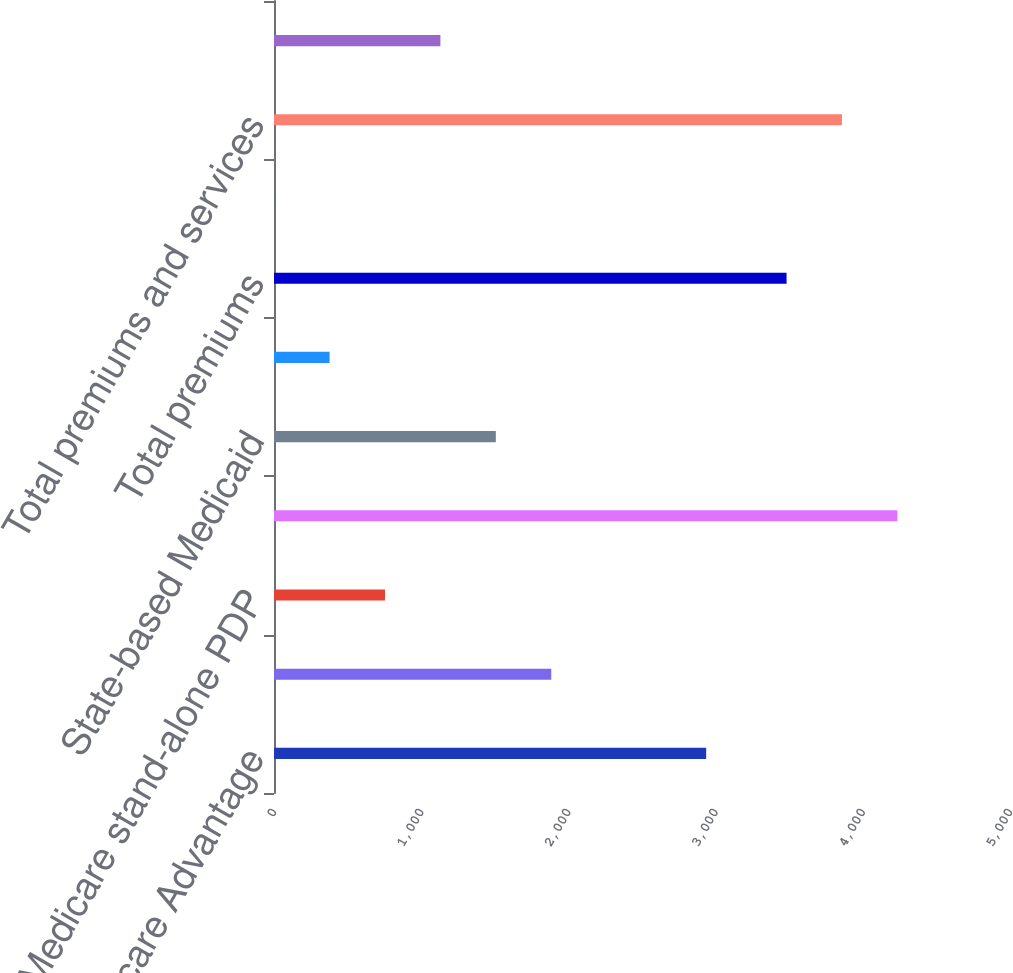<chart> <loc_0><loc_0><loc_500><loc_500><bar_chart><fcel>Individual Medicare Advantage<fcel>Group Medicare Advantage<fcel>Medicare stand-alone PDP<fcel>Total Retail Medicare<fcel>State-based Medicaid<fcel>Medicare Supplement<fcel>Total premiums<fcel>Services<fcel>Total premiums and services<fcel>Segment earnings<nl><fcel>2936<fcel>1883.5<fcel>754<fcel>4235<fcel>1507<fcel>377.5<fcel>3482<fcel>1<fcel>3858.5<fcel>1130.5<nl></chart> 